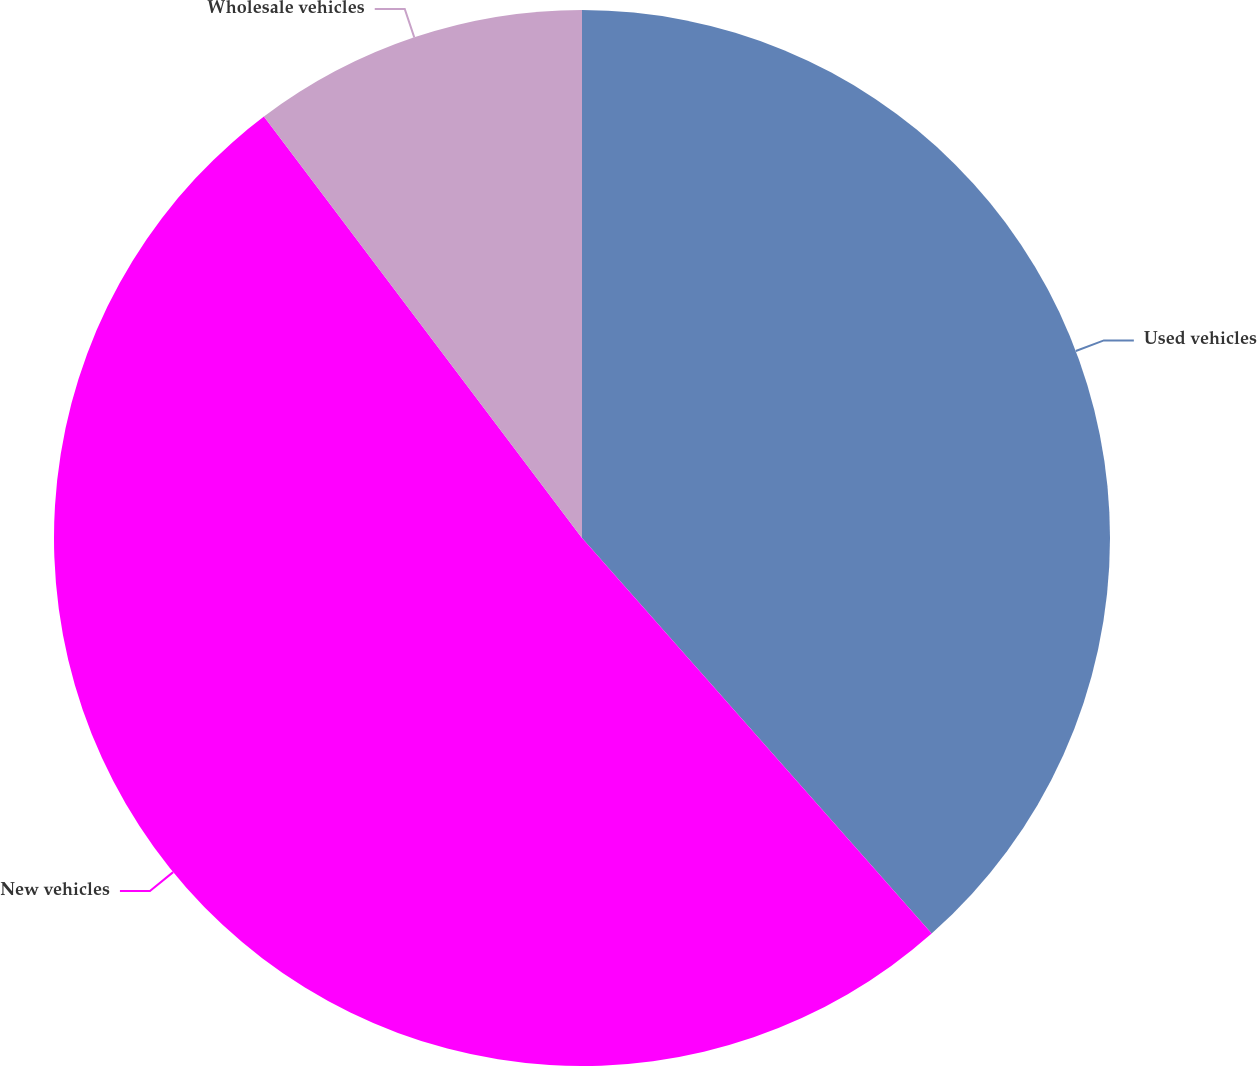Convert chart. <chart><loc_0><loc_0><loc_500><loc_500><pie_chart><fcel>Used vehicles<fcel>New vehicles<fcel>Wholesale vehicles<nl><fcel>38.48%<fcel>51.23%<fcel>10.29%<nl></chart> 